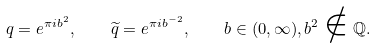<formula> <loc_0><loc_0><loc_500><loc_500>q = e ^ { \pi i b ^ { 2 } } , \quad \widetilde { q } = e ^ { \pi i b ^ { - 2 } } , \quad b \in ( 0 , \infty ) , b ^ { 2 } \notin \mathbb { Q } .</formula> 